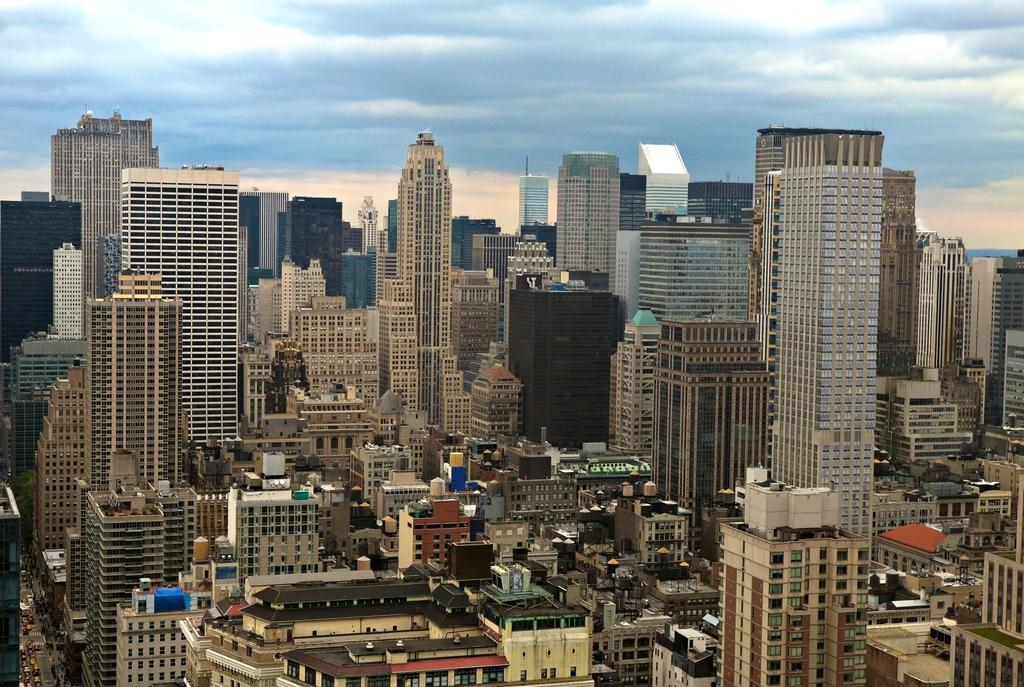What can be seen in the image that represents human-made structures? There are many buildings in the image. What is happening on the left side of the image? Vehicles are passing on the road on the left side of the image. What is visible at the top of the image? The sky is visible at the top of the image. What can be observed in the sky? Clouds are present in the sky. What type of cheese is being used to mark the buildings in the image? There is no cheese present in the image, and the buildings are not marked with any cheese. 